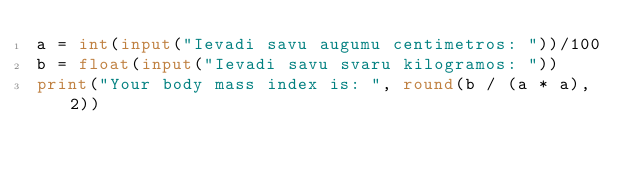<code> <loc_0><loc_0><loc_500><loc_500><_Python_>a = int(input("Ievadi savu augumu centimetros: "))/100
b = float(input("Ievadi savu svaru kilogramos: "))
print("Your body mass index is: ", round(b / (a * a), 2))</code> 